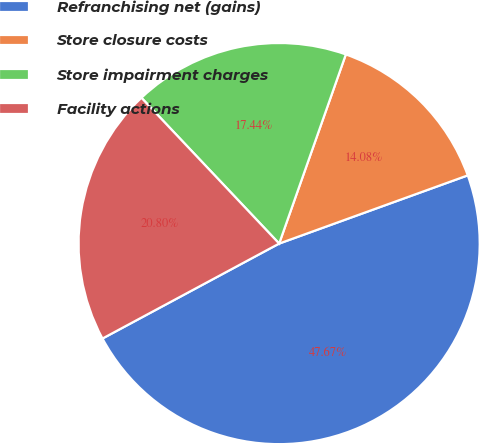<chart> <loc_0><loc_0><loc_500><loc_500><pie_chart><fcel>Refranchising net (gains)<fcel>Store closure costs<fcel>Store impairment charges<fcel>Facility actions<nl><fcel>47.67%<fcel>14.08%<fcel>17.44%<fcel>20.8%<nl></chart> 